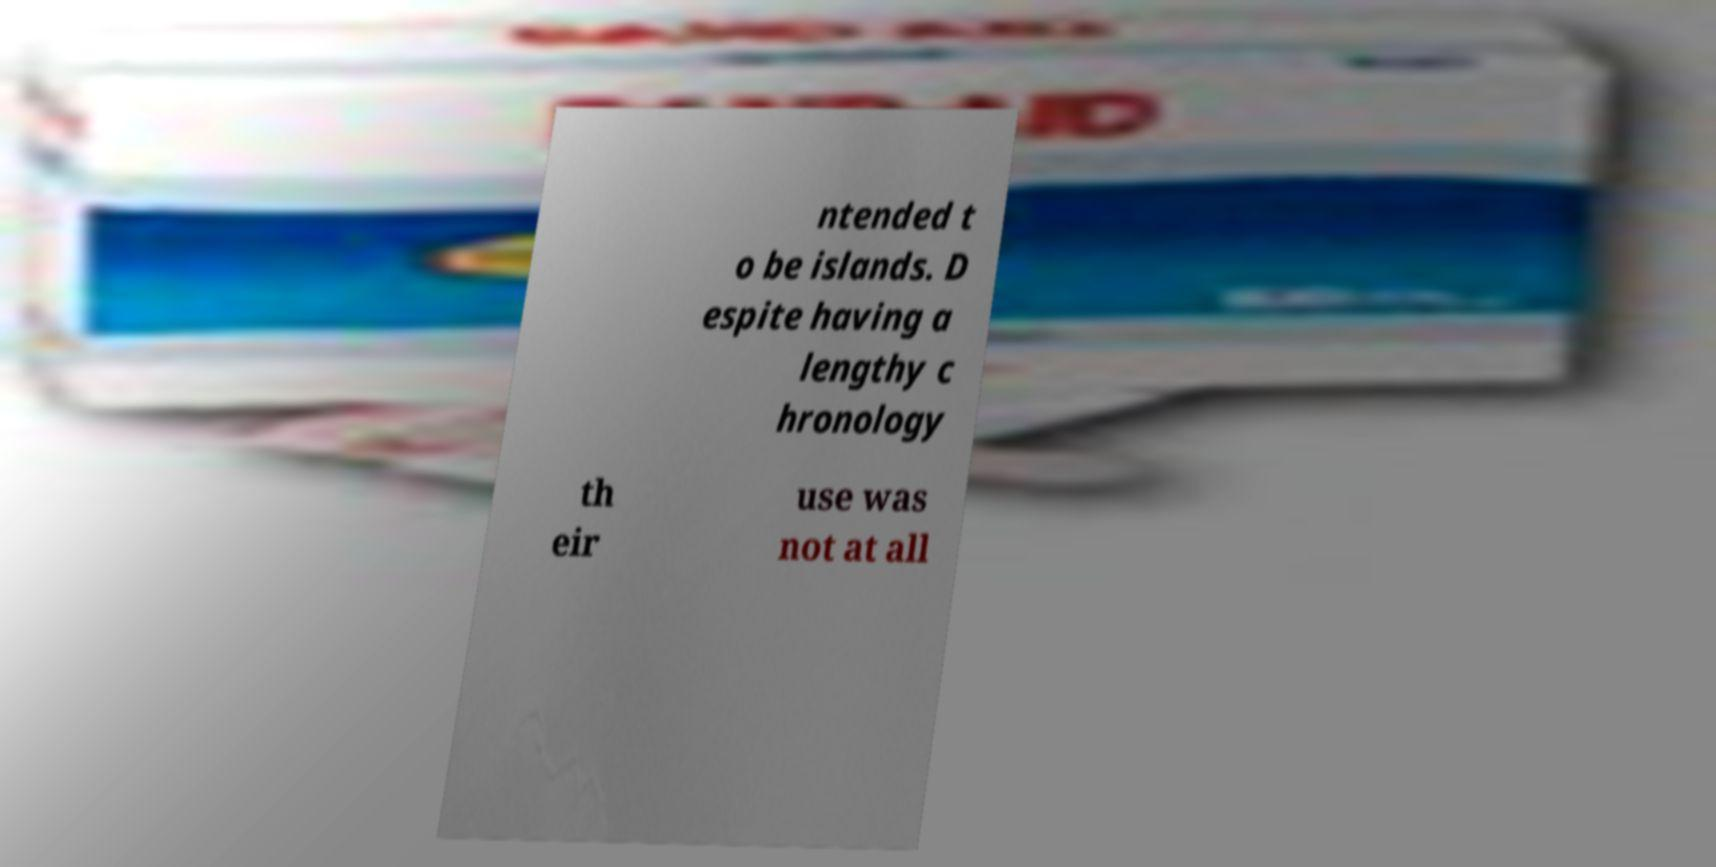Can you accurately transcribe the text from the provided image for me? ntended t o be islands. D espite having a lengthy c hronology th eir use was not at all 